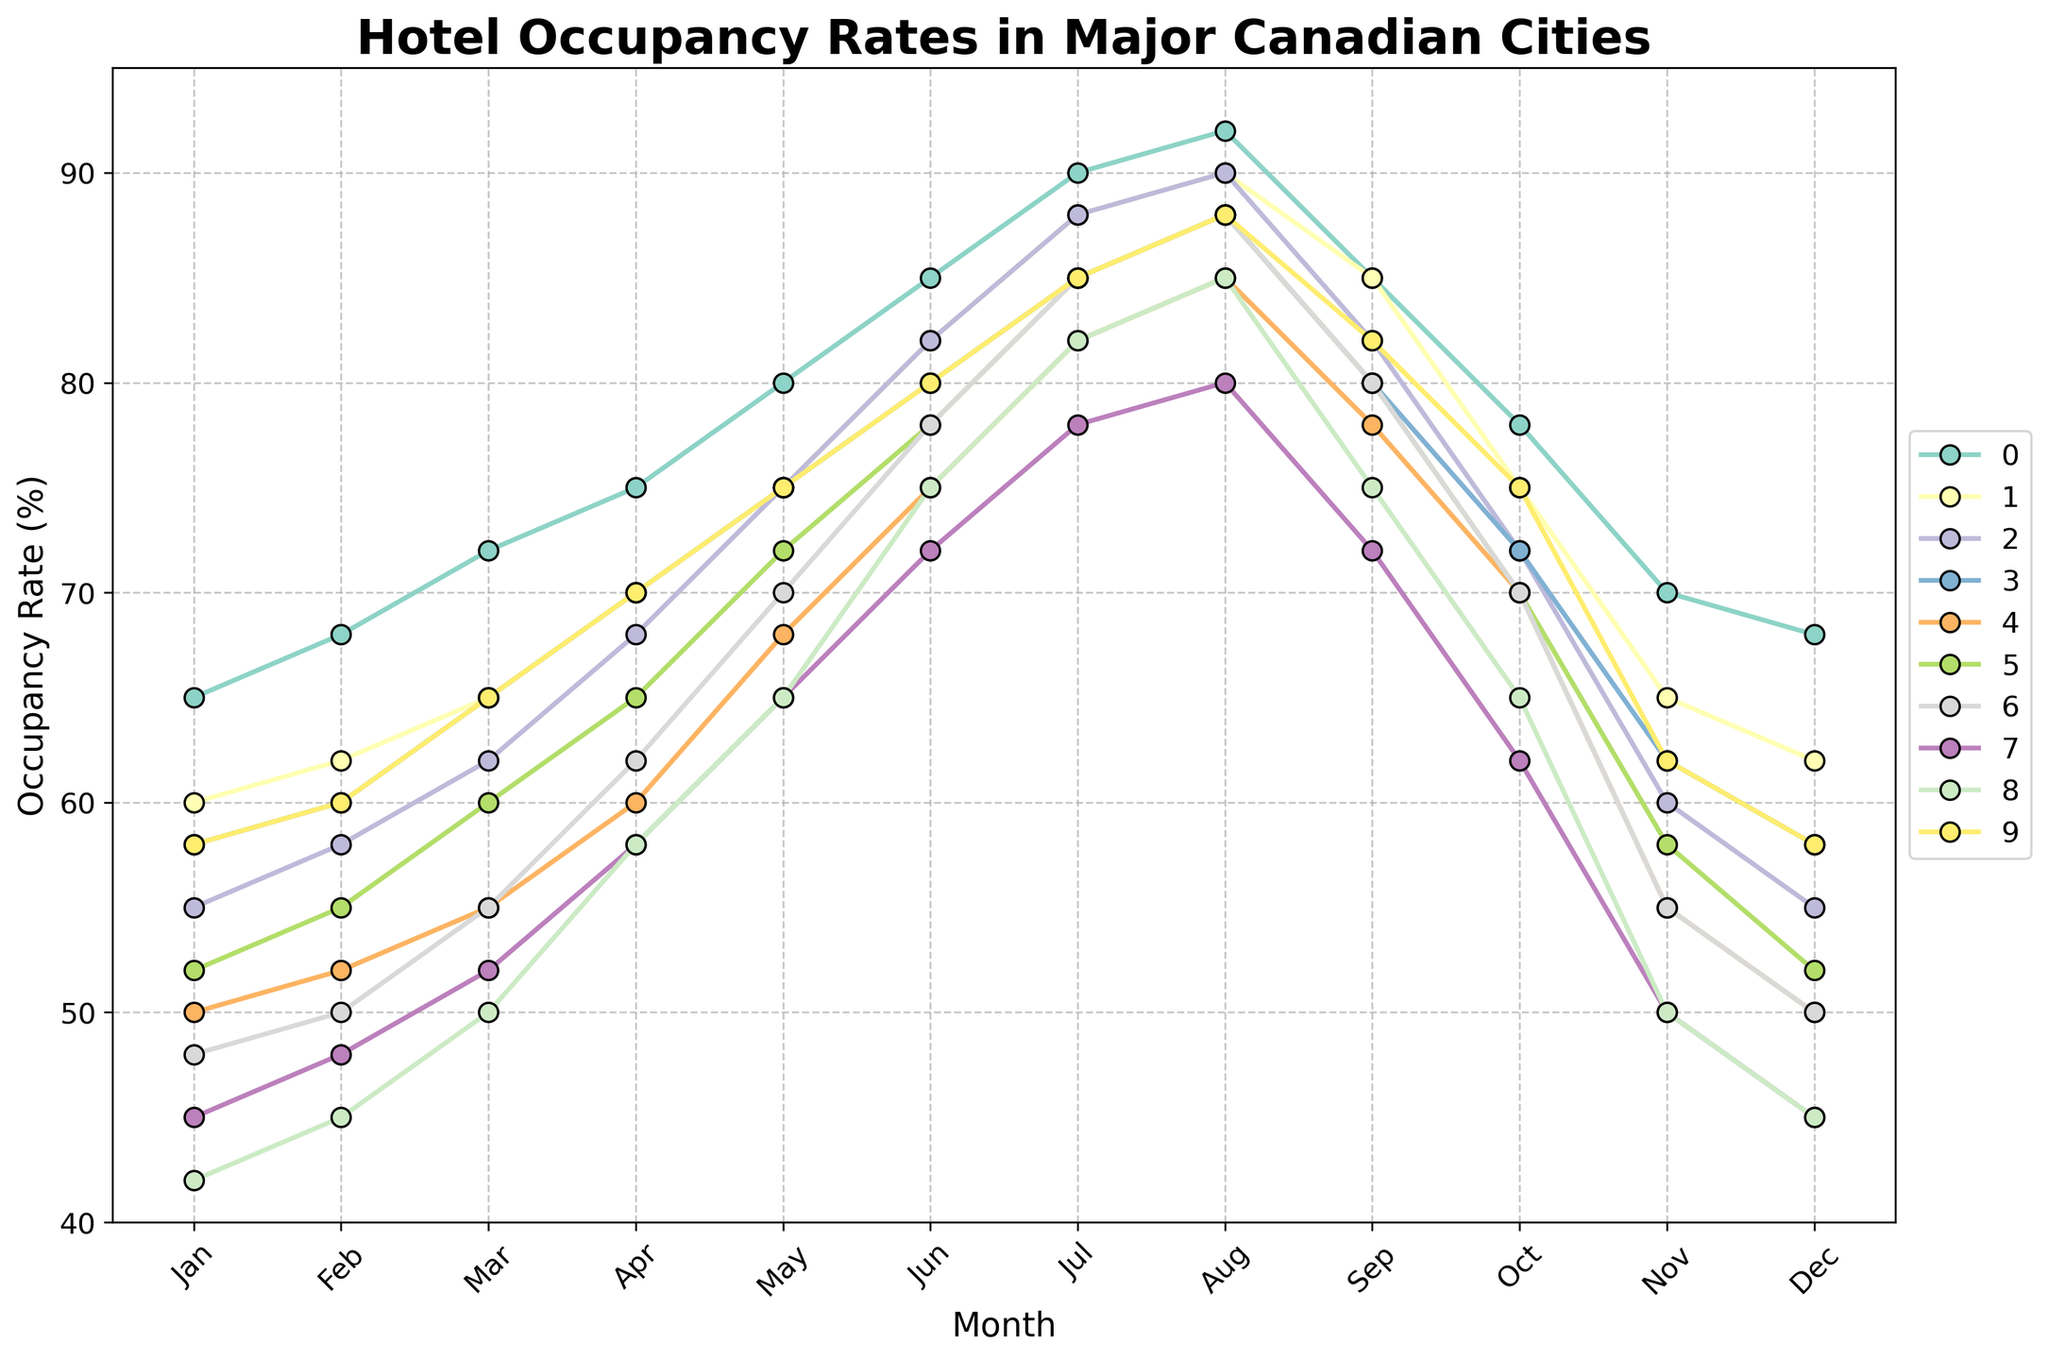Which city has the highest hotel occupancy rate in July? Check each city's occupancy rate for July from the lines on the plot. Toronto has the highest rate at 90%.
Answer: Toronto How does the hotel occupancy rate in Vancouver change from January to December? Follow the line representing Vancouver from January to December to see the trend. It gradually increases from 60% in January to 90% in August and then decreases back to 62% in December.
Answer: It increases from January to August, then decreases What is the average occupancy rate for Montreal in the second half of the year (July to December)? Add the occupancy rates for July (88), August (90), September (82), October (72), November (60), and December (55), then divide by 6. (88+90+82+72+60+55)/6 = 74.5
Answer: 74.5 Which month has the highest average occupancy rate across all cities? Calculate the average occupancy rate for each month by summing the rates from all cities and dividing by the number of cities (10). Find the month with the highest average. August has the highest average rate (88+90+90+88+85+88+88+80+85+88)/10 = 87.2.
Answer: August Do any two cities have the same hotel occupancy rate in May? If yes, which ones? Compare the lines for each city at May. Calgary and Ottawa both have an occupancy rate of 75%.
Answer: Calgary and Ottawa Which city shows the most significant increase in occupancy rate from January to June? Calculate the difference in occupancy rates for each city between June and January. Toronto has the most significant increase from 65% to 85%, a difference of 20%.
Answer: Toronto What is the occupancy rate for Victoria in October? Locate the line representing Victoria and read the rate for October, which is 75%.
Answer: 75% Among the cities with occupancy rates below 50% in January, which city has the highest rate in December? Identify cities with less than 50% in January, then check their December rates. Edmonton has 45% in January and 45% in December. Winnipeg has 42% in January and 45% in December. Both reach 45%, but no increase from January.
Answer: Edmonton What's the difference in occupancy rates between the highest and lowest month for Quebec City? Find Quebec City's highest rate (85% in August) and lowest rate (50% in January and December). The difference is 85 - 50 = 35.
Answer: 35 How do the occupancy rates of Ottawa compare to Halifax throughout the year? Compare each month's occupancy rates between Ottawa and Halifax by observing their lines. Both cities show a similar trend with increases toward the middle of the year and decreases towards December, with Ottawa generally having slightly higher rates.
Answer: Ottawa generally higher 